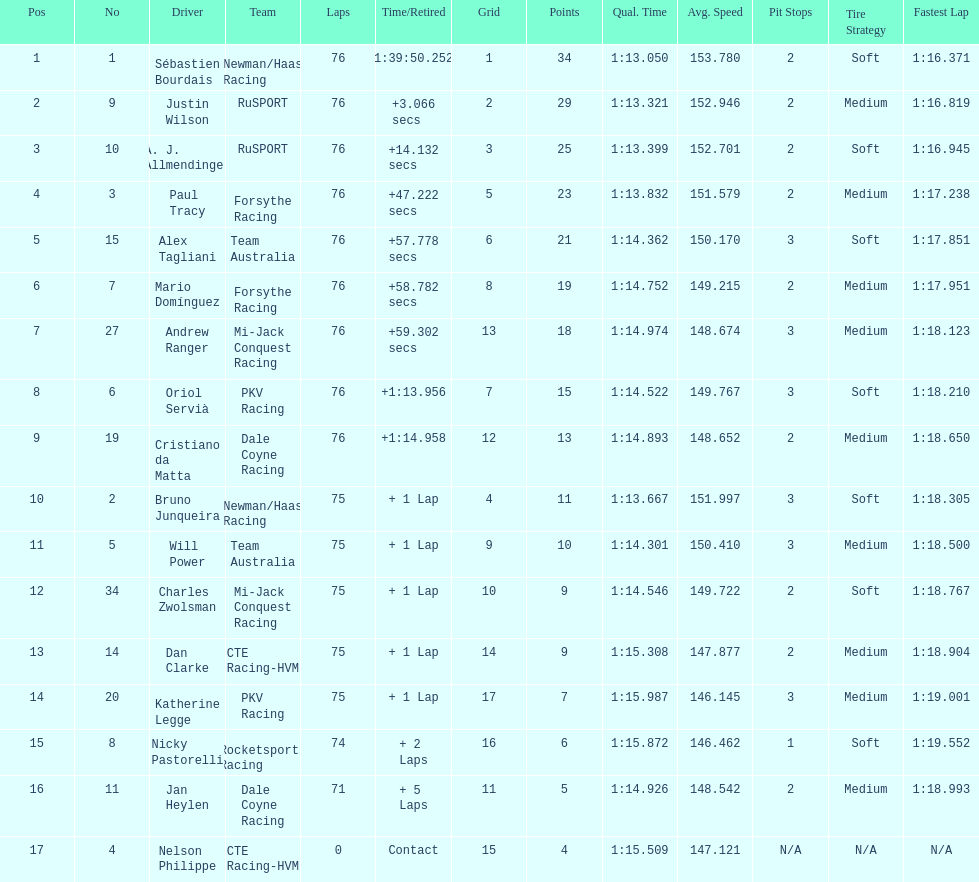What driver earned the most points? Sebastien Bourdais. 